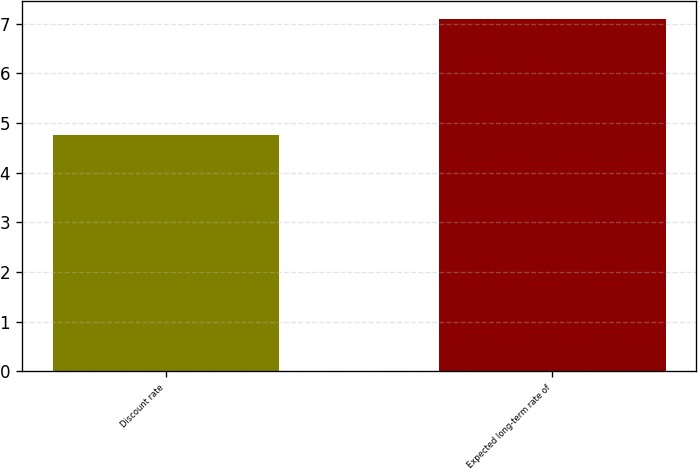<chart> <loc_0><loc_0><loc_500><loc_500><bar_chart><fcel>Discount rate<fcel>Expected long-term rate of<nl><fcel>4.75<fcel>7.1<nl></chart> 